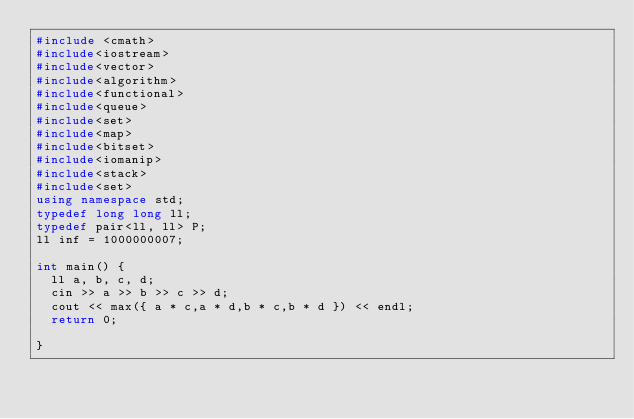<code> <loc_0><loc_0><loc_500><loc_500><_C++_>#include <cmath>
#include<iostream>
#include<vector>
#include<algorithm>
#include<functional>
#include<queue>
#include<set>
#include<map>
#include<bitset>
#include<iomanip>
#include<stack>
#include<set>
using namespace std;
typedef long long ll;
typedef pair<ll, ll> P;
ll inf = 1000000007;

int main() {
	ll a, b, c, d;
	cin >> a >> b >> c >> d;
	cout << max({ a * c,a * d,b * c,b * d }) << endl;
	return 0;
	
}</code> 